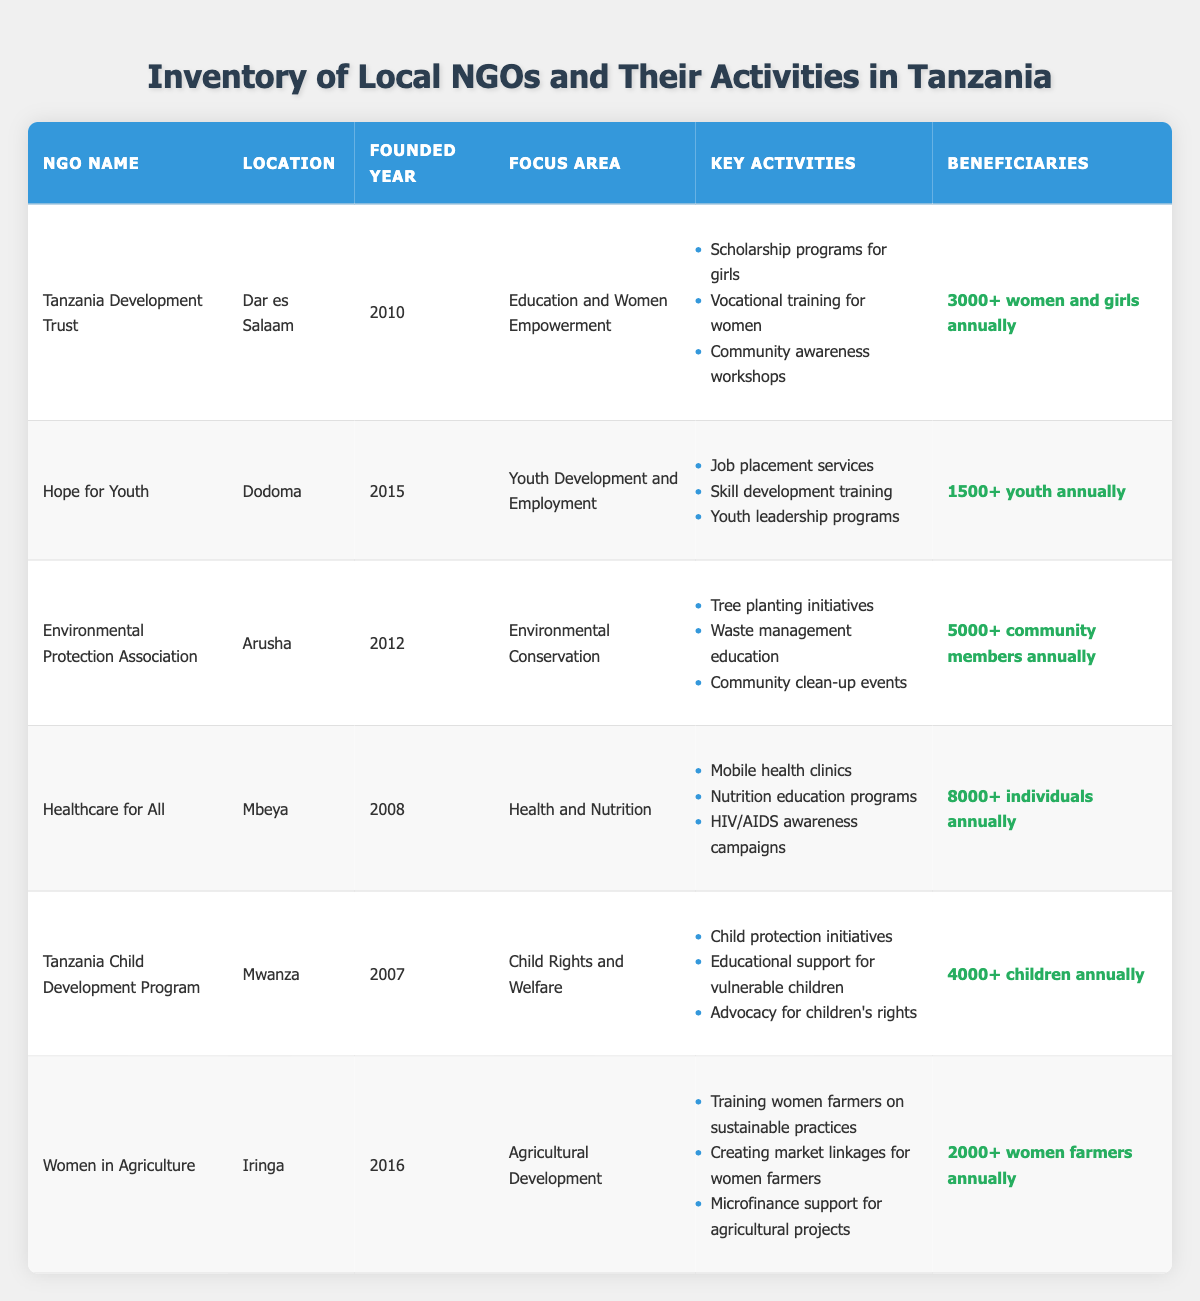What is the focus area of the NGO located in Dar es Salaam? The NGO located in Dar es Salaam is the Tanzania Development Trust, which focuses on "Education and Women Empowerment" as mentioned in the table under the "Focus Area" column.
Answer: Education and Women Empowerment Which NGO has the highest number of beneficiaries annually? By examining the "Beneficiaries" column, Healthcare for All reports 8000+ individuals annually, which is higher than the others, confirming it has the highest number of beneficiaries.
Answer: Healthcare for All Is the Women in Agriculture NGO focused on environmental activities? The Women in Agriculture NGO focuses on agricultural development, not environmental activities, as its listed focus area does not include conservation or environmental issues.
Answer: No How many women and girls are served by the Tanzania Development Trust annually? According to the "Beneficiaries" data of the Tanzania Development Trust, it serves over 3000 women and girls each year, which is directly mentioned in the table.
Answer: 3000+ women and girls annually What is the average number of beneficiaries across all NGOs listed? To find the average: First, add the estimated beneficiaries for each NGO: 3000 (Tanzania Development Trust) + 1500 (Hope for Youth) + 5000 (Environmental Protection Association) + 8000 (Healthcare for All) + 4000 (Tanzania Child Development Program) + 2000 (Women in Agriculture) = 23500. Then, there are 6 NGOs, so the average is 23500/6 = approximately 3917.
Answer: Approximately 3917 How many NGOs were founded before 2010? By checking the "Founded Year" column, the NGOs founded before 2010 are Healthcare for All (2008), and Tanzania Child Development Program (2007). Therefore, there are two NGOs founded before 2010.
Answer: 2 Is there any NGO that operates in Mwanza? Yes, the Tanzania Child Development Program operates in Mwanza, as indicated in the "Location" column of the table.
Answer: Yes Which NGO has a focus on youth development? The NGO focused on youth development is Hope for Youth, as it specifically mentions "Youth Development and Employment" in the "Focus Area" section of the table.
Answer: Hope for Youth What are the key activities offered by the Environmental Protection Association? The Environmental Protection Association offers tree planting initiatives, waste management education, and community clean-up events, all detailed in the "Key Activities" section in the table.
Answer: Tree planting initiatives, waste management education, community clean-up events 